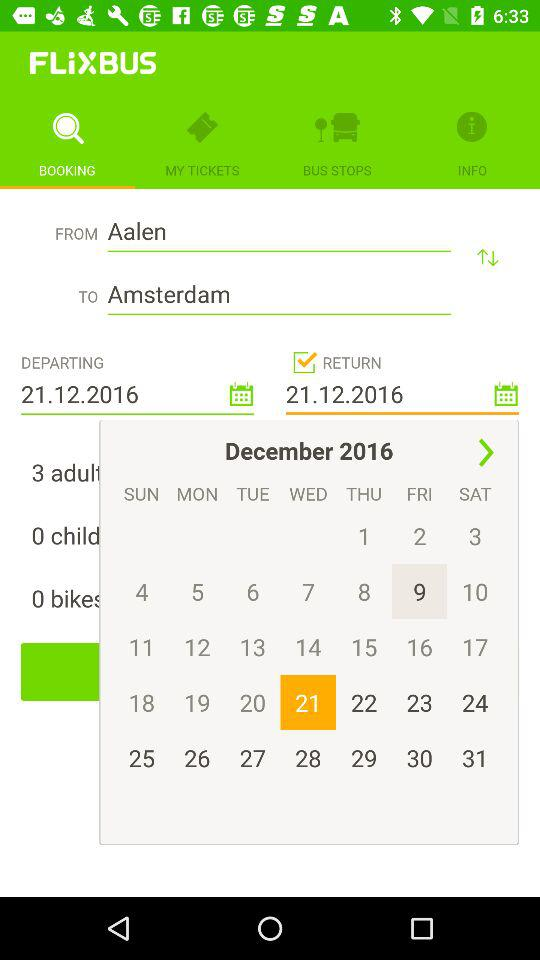How many adults are there? There are 3 adults. 